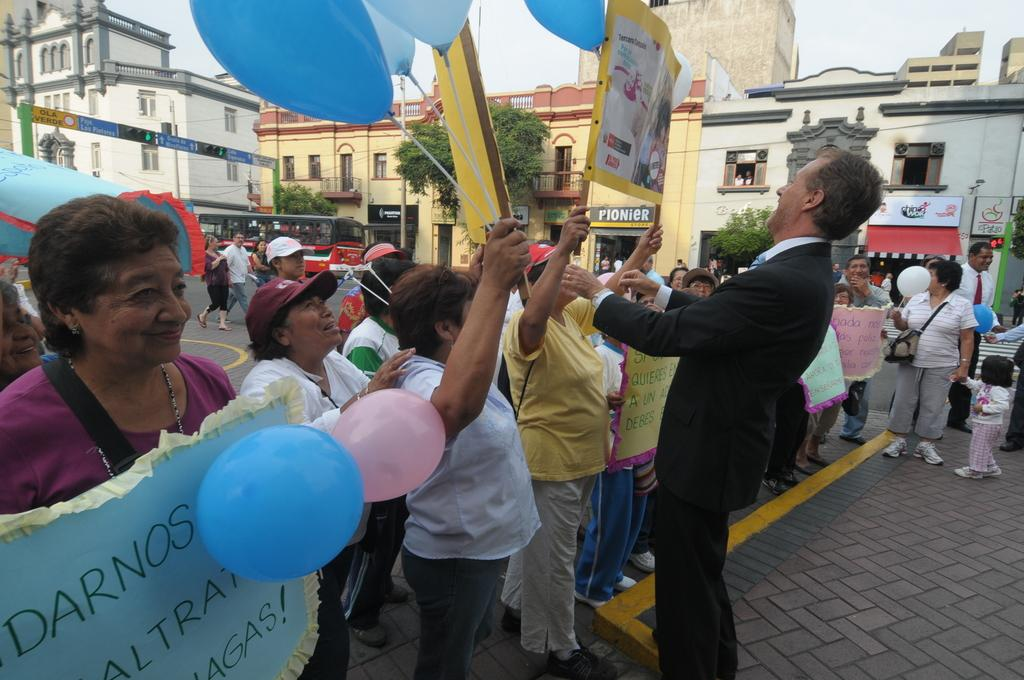How many persons are in the image? There is a group of persons in the image. What are the persons in the image doing? The persons are standing with charts. Where is the scene taking place? The scene takes place on a road. What can be seen in the background of the image? There are buildings, sign boards, poles, trees, a vehicle, and persons on the road in the background of the image. Can you tell me how many rifles are visible in the image? There are no rifles present in the image. Is there a lake visible in the background of the image? There is no lake visible in the image; only a road, buildings, sign boards, poles, trees, a vehicle, and persons on the road are present in the background. 